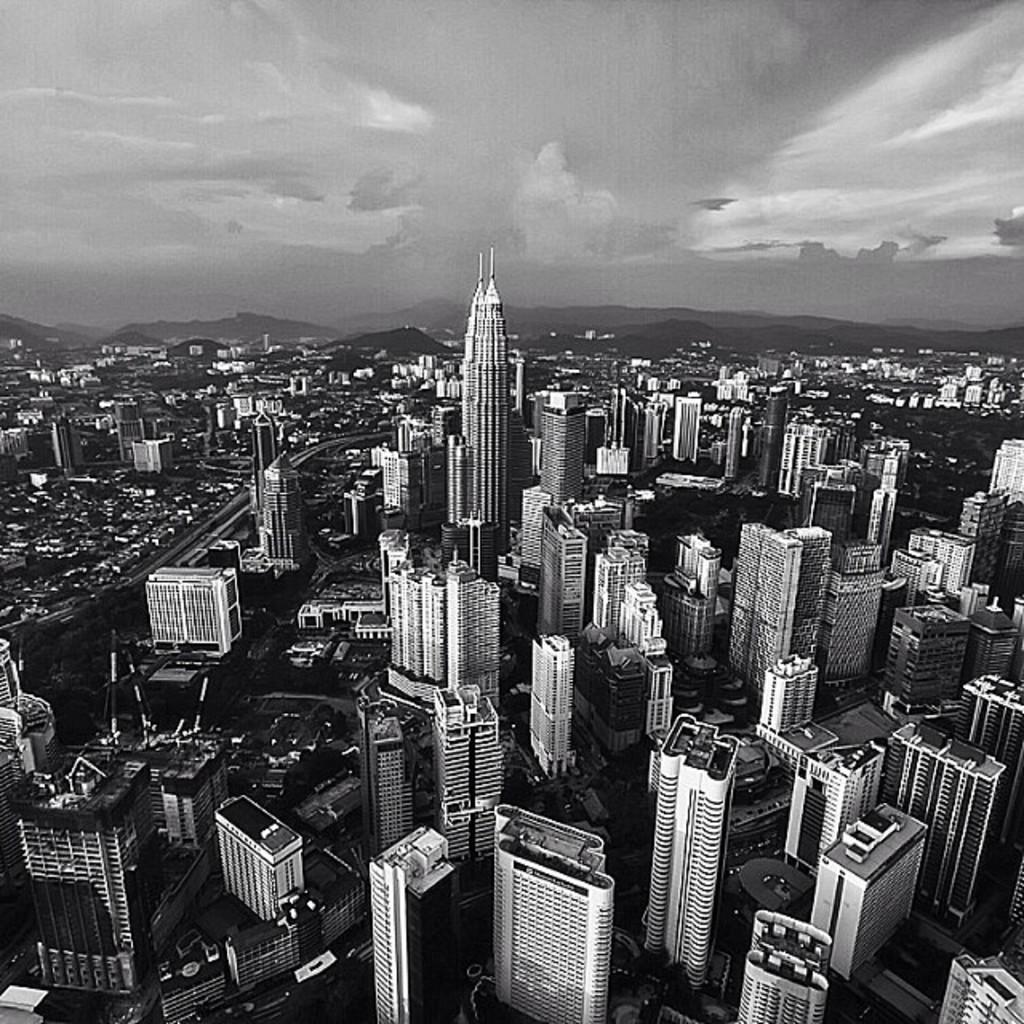How would you summarize this image in a sentence or two? In this picture we can observe a city with large numbers of tall buildings. We can observe a tall building here. In the background there are hills and a sky with clouds. 